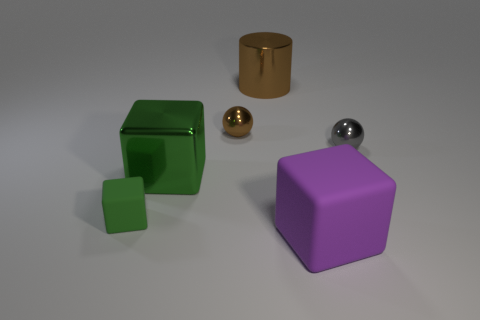What number of brown cylinders are the same size as the gray ball?
Provide a succinct answer. 0. Is the number of gray metal things in front of the small green rubber cube less than the number of tiny brown spheres?
Provide a succinct answer. Yes. What is the size of the sphere in front of the ball that is behind the gray thing?
Your answer should be very brief. Small. How many objects are either green shiny balls or big purple objects?
Make the answer very short. 1. Are there any big shiny objects of the same color as the large rubber object?
Your answer should be very brief. No. Is the number of big objects less than the number of small gray shiny spheres?
Offer a very short reply. No. How many objects are small brown cylinders or rubber objects in front of the green matte thing?
Offer a terse response. 1. Is there a big red cylinder made of the same material as the small green thing?
Ensure brevity in your answer.  No. What material is the green thing that is the same size as the purple object?
Provide a short and direct response. Metal. The cube in front of the matte object to the left of the big brown metal object is made of what material?
Your response must be concise. Rubber. 